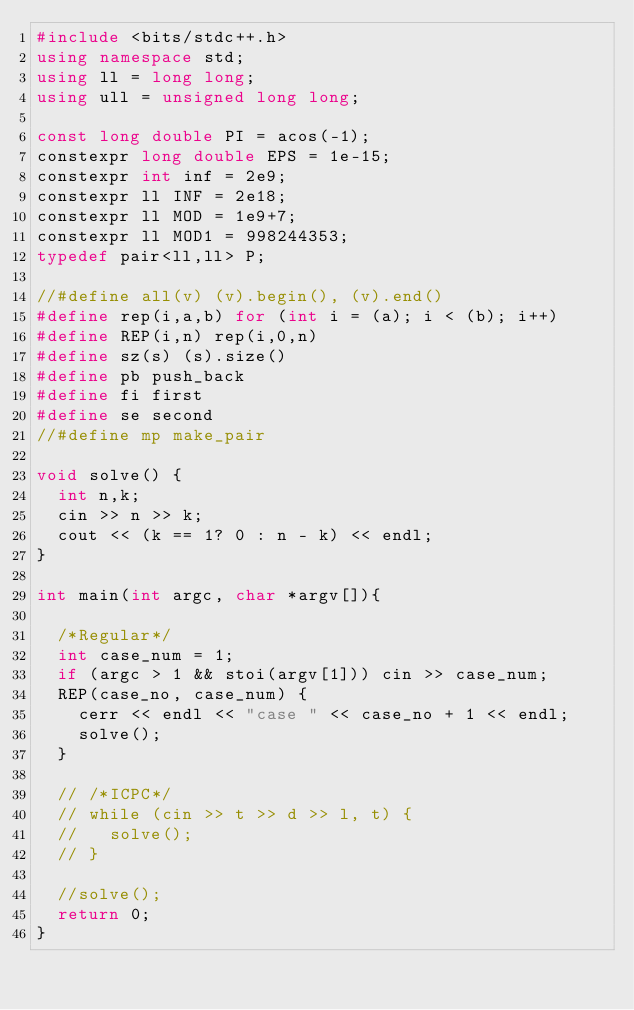<code> <loc_0><loc_0><loc_500><loc_500><_C++_>#include <bits/stdc++.h>
using namespace std;
using ll = long long;
using ull = unsigned long long;

const long double PI = acos(-1);
constexpr long double EPS = 1e-15;
constexpr int inf = 2e9;
constexpr ll INF = 2e18;
constexpr ll MOD = 1e9+7;
constexpr ll MOD1 = 998244353;
typedef pair<ll,ll> P;

//#define all(v) (v).begin(), (v).end()
#define rep(i,a,b) for (int i = (a); i < (b); i++)
#define REP(i,n) rep(i,0,n)
#define sz(s) (s).size()
#define pb push_back
#define fi first
#define se second
//#define mp make_pair

void solve() {
  int n,k;
  cin >> n >> k;
  cout << (k == 1? 0 : n - k) << endl;
}

int main(int argc, char *argv[]){

  /*Regular*/
  int case_num = 1;
  if (argc > 1 && stoi(argv[1])) cin >> case_num;
  REP(case_no, case_num) {
    cerr << endl << "case " << case_no + 1 << endl;
    solve();
  }

  // /*ICPC*/
  // while (cin >> t >> d >> l, t) {
  //   solve();
  // }

  //solve();
  return 0;
}</code> 